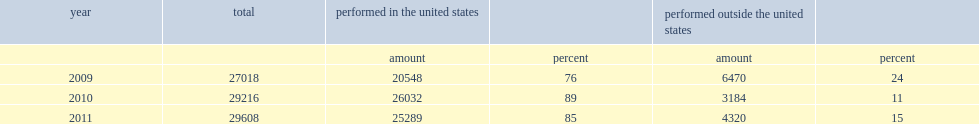In 2011, how many million dollars did u.s.-located companies spend for extramural (purchased and collaborative) research and development performed by domestic and overseas organizations? 29608.0. How many million dollars were most of the 2011 extramural r&d performed by u.s.-located organizations? 25289.0. How many percent was most of the 2011 extramural r&d performed by u.s.-located organizations? 0.854127. In 2009, what was the share of extramural r&d expenditures paid for by u.s.-located firms and performed overseas? 24.0. In 2010, what was the share of extramural r&d expenditures paid for by u.s.-located firms and performed overseas? 11.0. 